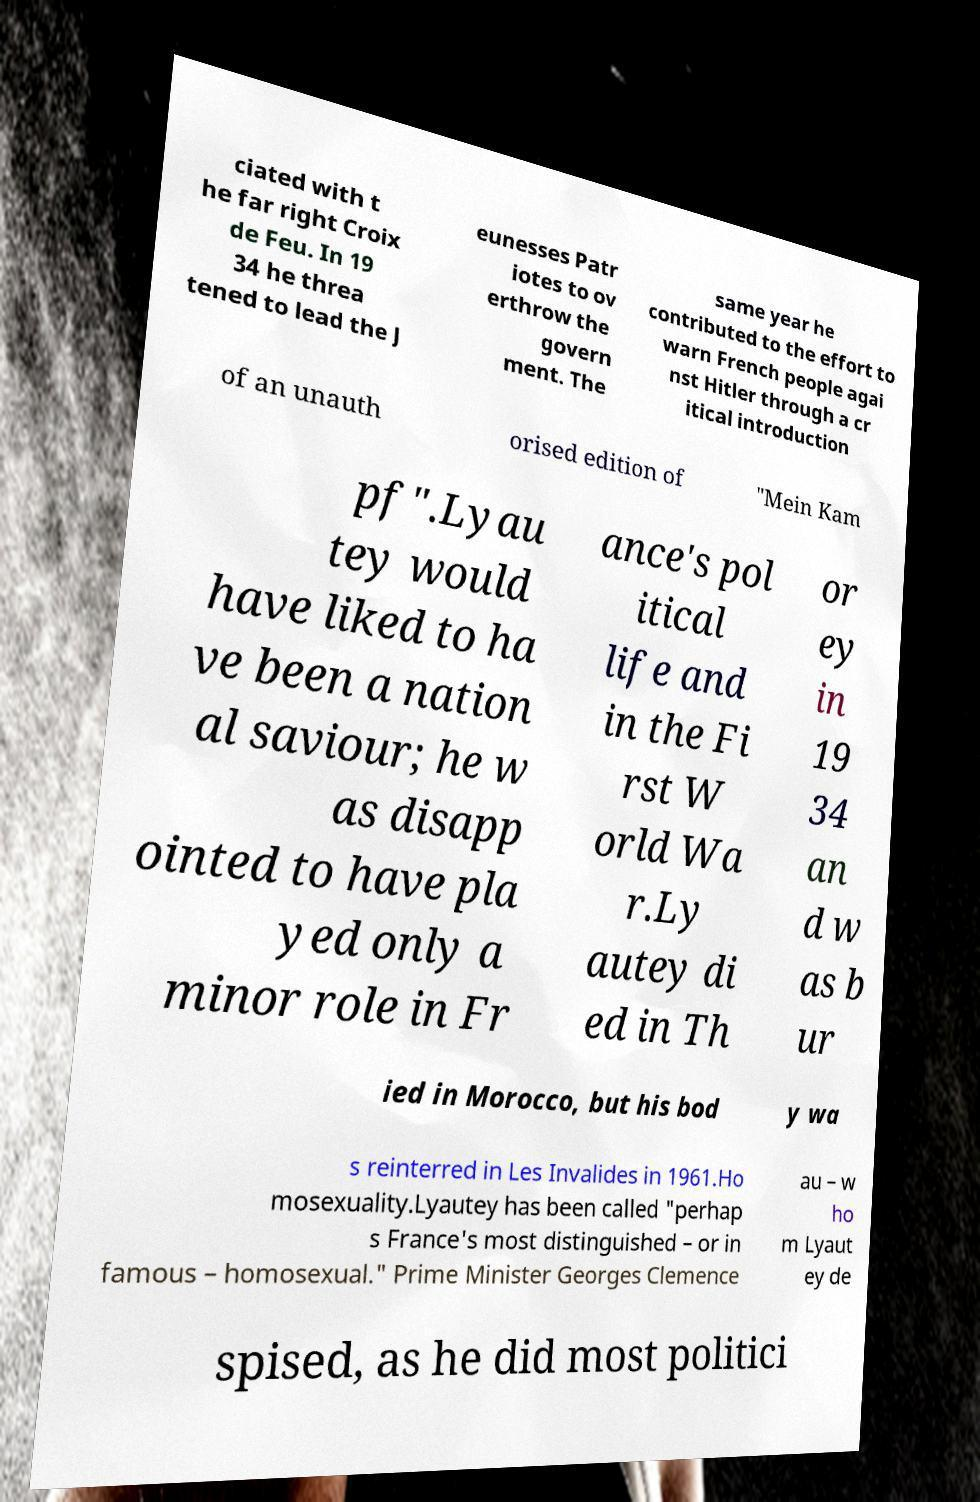Can you read and provide the text displayed in the image?This photo seems to have some interesting text. Can you extract and type it out for me? ciated with t he far right Croix de Feu. In 19 34 he threa tened to lead the J eunesses Patr iotes to ov erthrow the govern ment. The same year he contributed to the effort to warn French people agai nst Hitler through a cr itical introduction of an unauth orised edition of "Mein Kam pf".Lyau tey would have liked to ha ve been a nation al saviour; he w as disapp ointed to have pla yed only a minor role in Fr ance's pol itical life and in the Fi rst W orld Wa r.Ly autey di ed in Th or ey in 19 34 an d w as b ur ied in Morocco, but his bod y wa s reinterred in Les Invalides in 1961.Ho mosexuality.Lyautey has been called "perhap s France's most distinguished – or in famous – homosexual." Prime Minister Georges Clemence au – w ho m Lyaut ey de spised, as he did most politici 